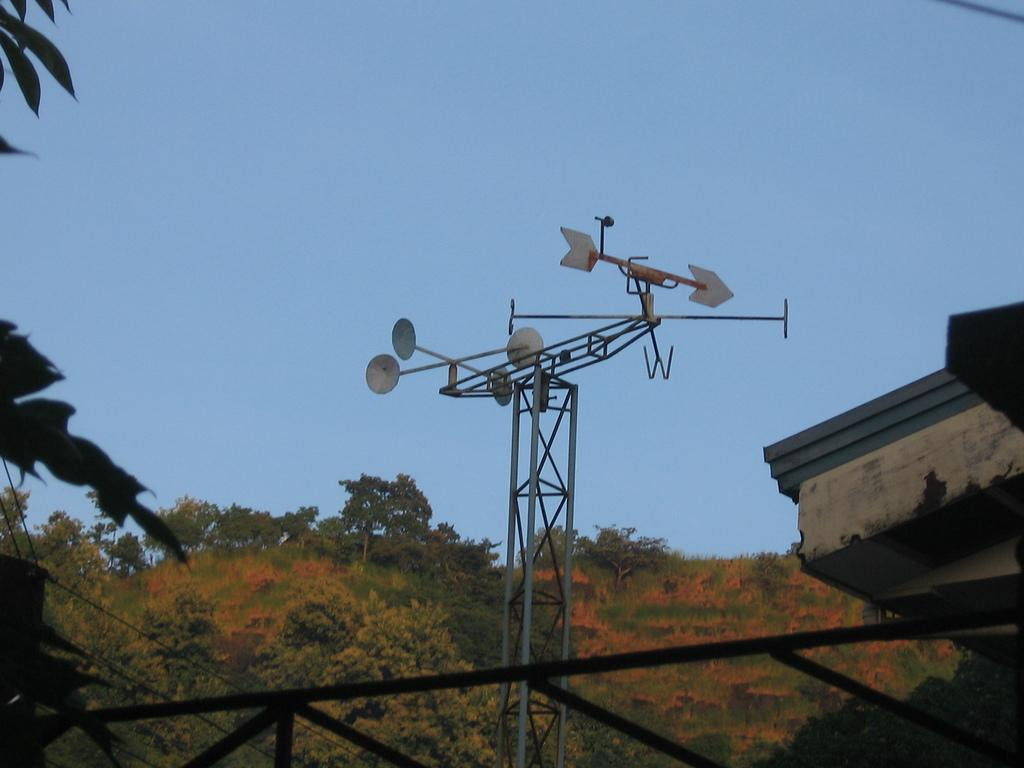What is located on top of the tower in the image? There is an antenna on top of the tower in the image. What can be seen behind the tower in the image? There are trees visible behind the tower in the image. Where are the pizzas stored in the image? There are no pizzas present in the image. What type of flooring can be seen in the image? The image does not show any flooring, as it primarily features a tower with an antenna and trees in the background. 